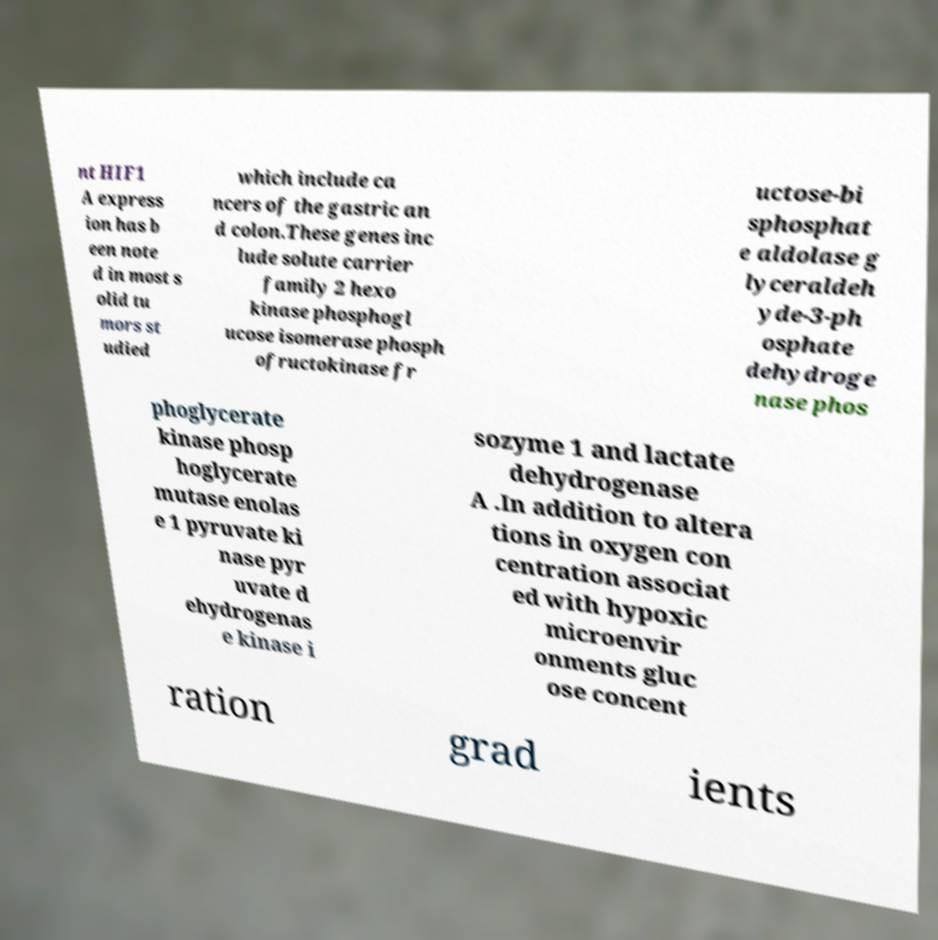There's text embedded in this image that I need extracted. Can you transcribe it verbatim? nt HIF1 A express ion has b een note d in most s olid tu mors st udied which include ca ncers of the gastric an d colon.These genes inc lude solute carrier family 2 hexo kinase phosphogl ucose isomerase phosph ofructokinase fr uctose-bi sphosphat e aldolase g lyceraldeh yde-3-ph osphate dehydroge nase phos phoglycerate kinase phosp hoglycerate mutase enolas e 1 pyruvate ki nase pyr uvate d ehydrogenas e kinase i sozyme 1 and lactate dehydrogenase A .In addition to altera tions in oxygen con centration associat ed with hypoxic microenvir onments gluc ose concent ration grad ients 